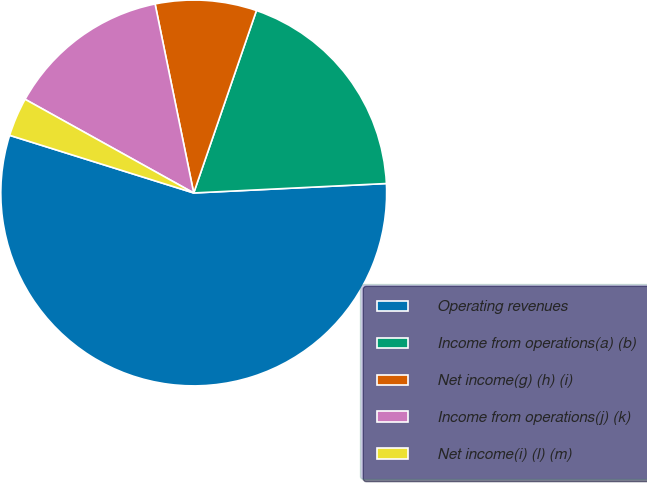Convert chart. <chart><loc_0><loc_0><loc_500><loc_500><pie_chart><fcel>Operating revenues<fcel>Income from operations(a) (b)<fcel>Net income(g) (h) (i)<fcel>Income from operations(j) (k)<fcel>Net income(i) (l) (m)<nl><fcel>55.61%<fcel>18.95%<fcel>8.48%<fcel>13.72%<fcel>3.24%<nl></chart> 